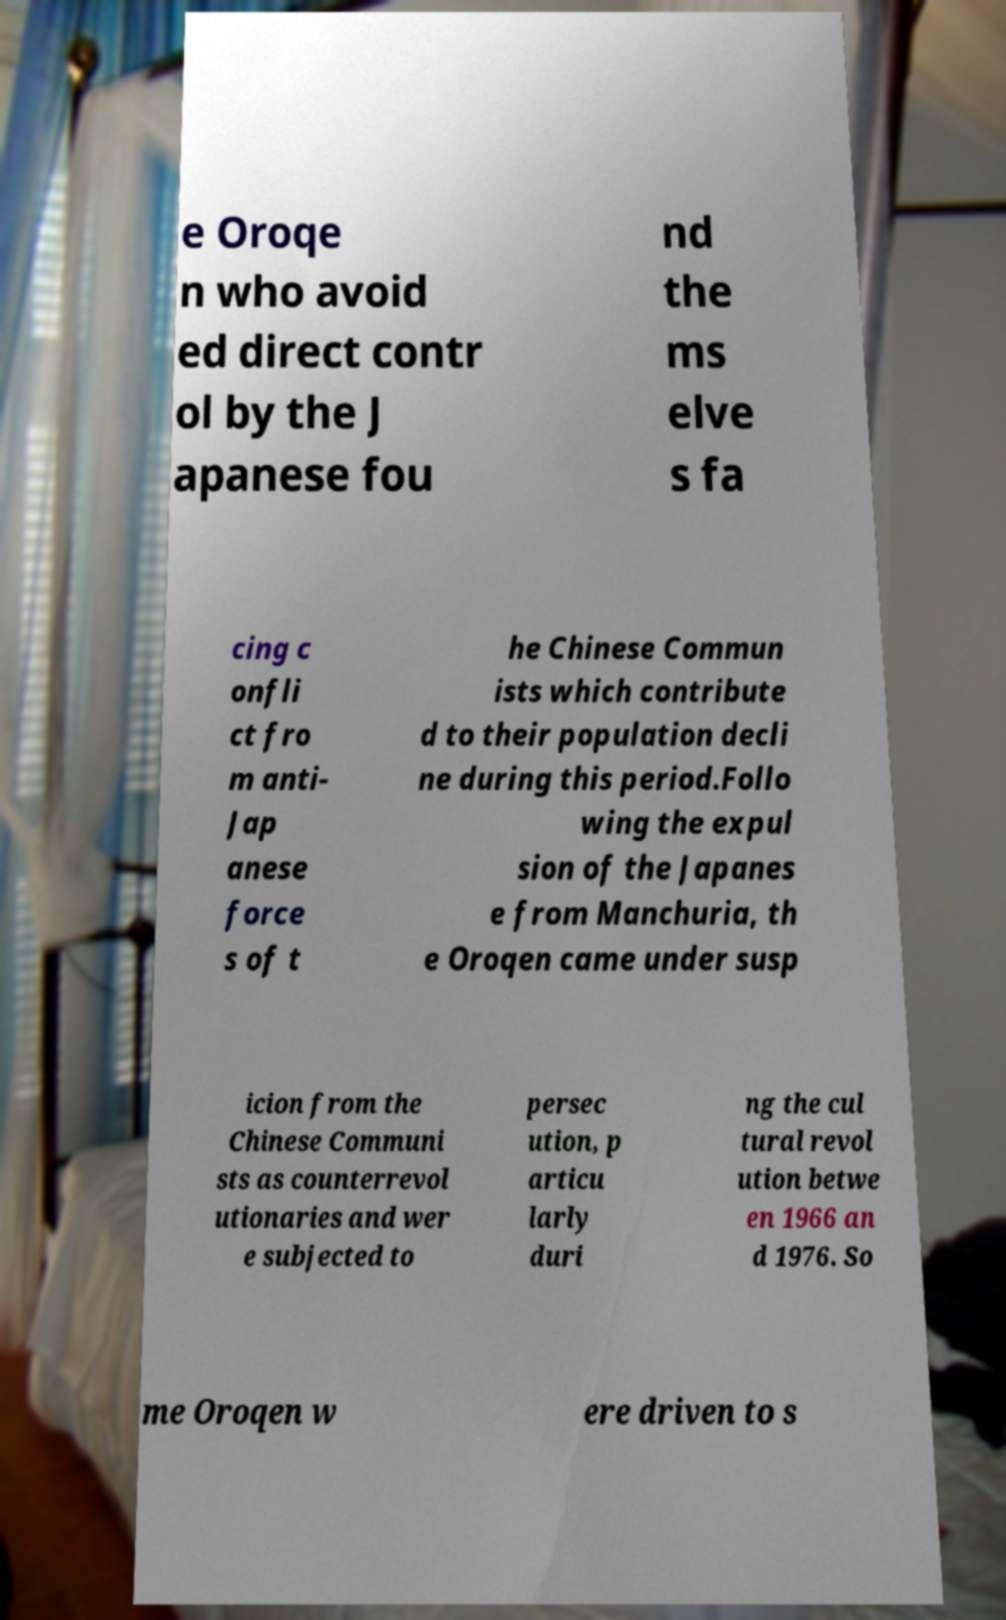Please identify and transcribe the text found in this image. e Oroqe n who avoid ed direct contr ol by the J apanese fou nd the ms elve s fa cing c onfli ct fro m anti- Jap anese force s of t he Chinese Commun ists which contribute d to their population decli ne during this period.Follo wing the expul sion of the Japanes e from Manchuria, th e Oroqen came under susp icion from the Chinese Communi sts as counterrevol utionaries and wer e subjected to persec ution, p articu larly duri ng the cul tural revol ution betwe en 1966 an d 1976. So me Oroqen w ere driven to s 